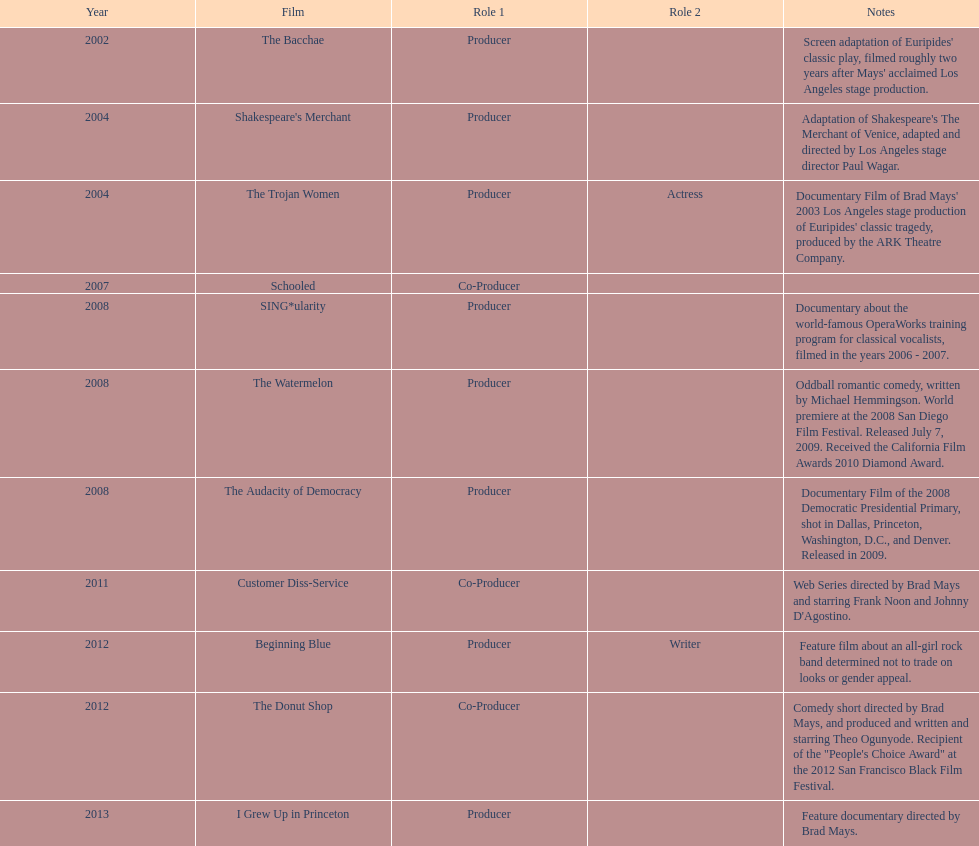Which film was before the audacity of democracy? The Watermelon. 